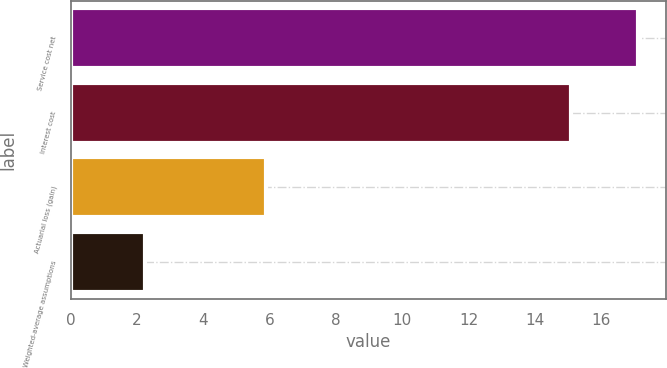Convert chart. <chart><loc_0><loc_0><loc_500><loc_500><bar_chart><fcel>Service cost net<fcel>Interest cost<fcel>Actuarial loss (gain)<fcel>Weighted-average assumptions<nl><fcel>17.1<fcel>15.1<fcel>5.9<fcel>2.25<nl></chart> 